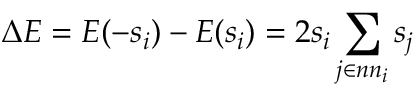Convert formula to latex. <formula><loc_0><loc_0><loc_500><loc_500>\Delta E = E ( - s _ { i } ) - E ( s _ { i } ) = 2 s _ { i } \sum _ { j \in n n _ { i } } s _ { j }</formula> 